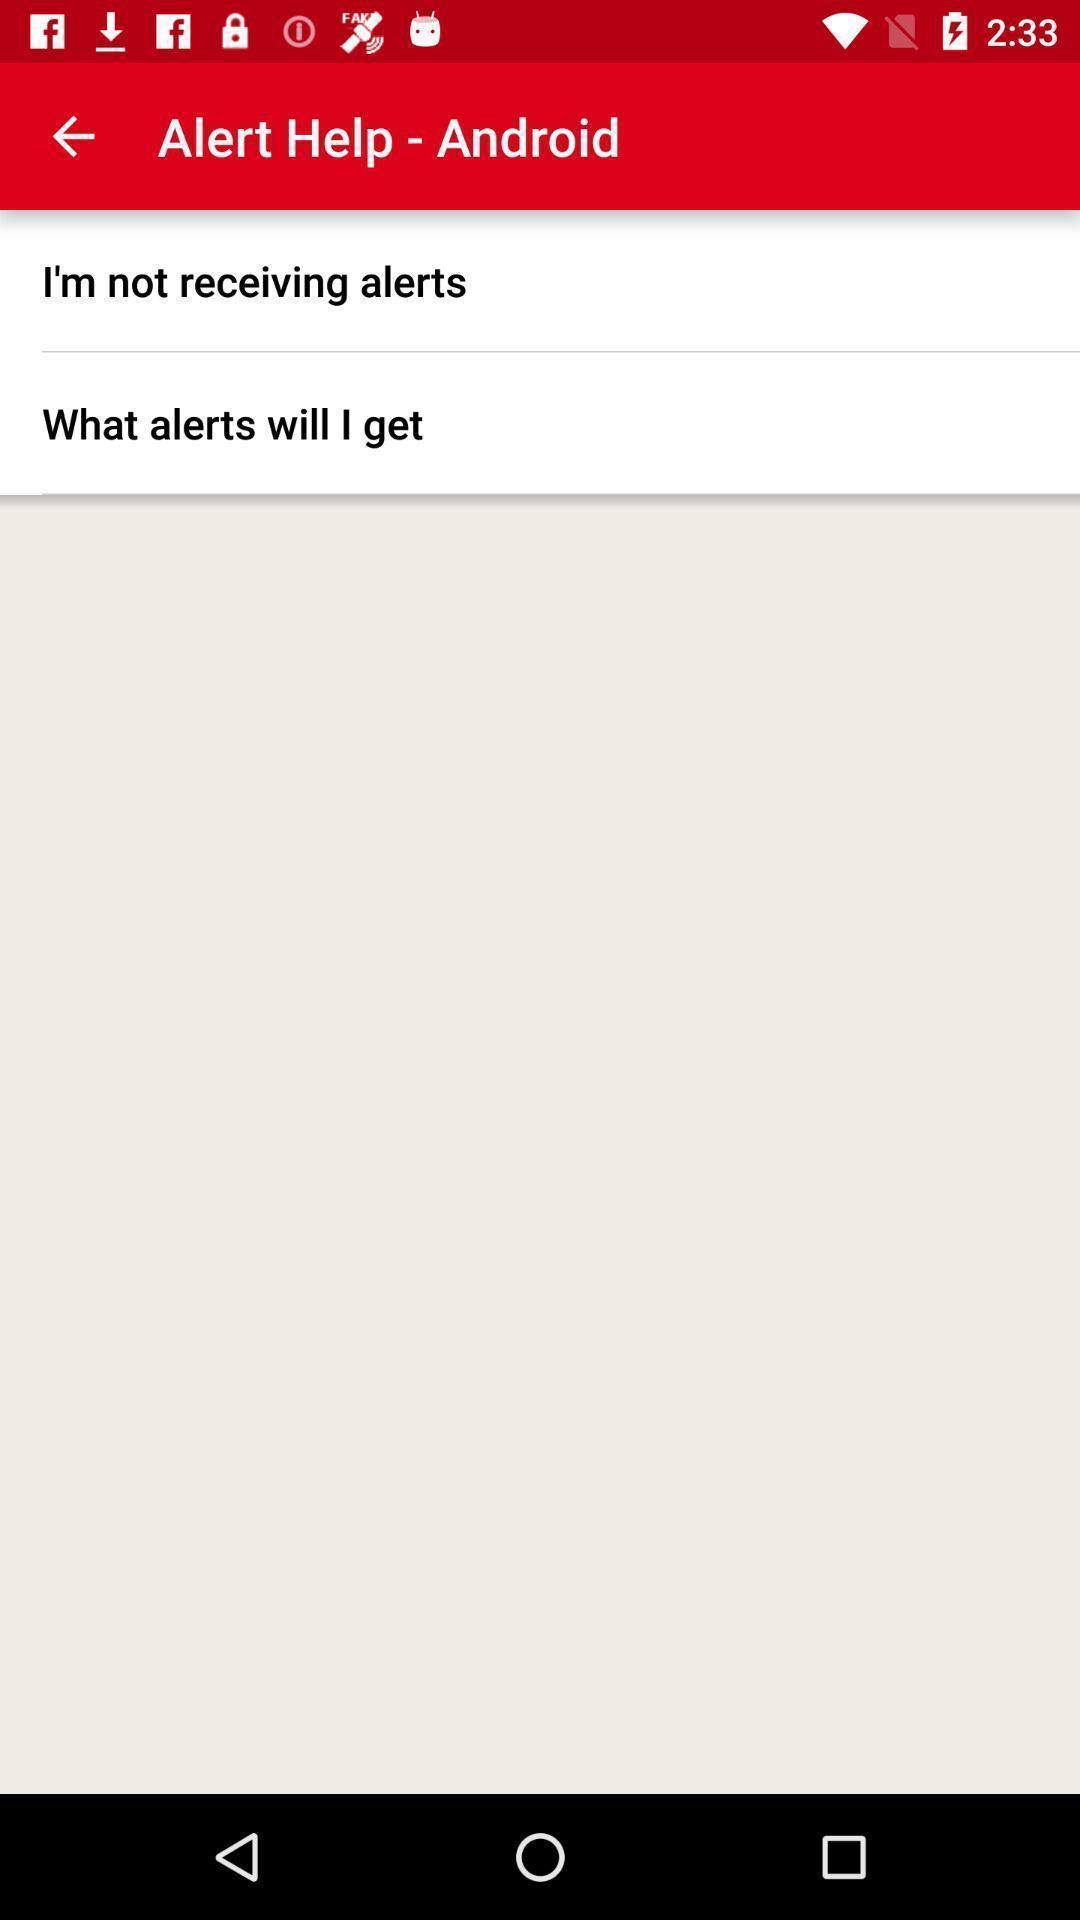Explain what's happening in this screen capture. Screen shows about alert help on android. 